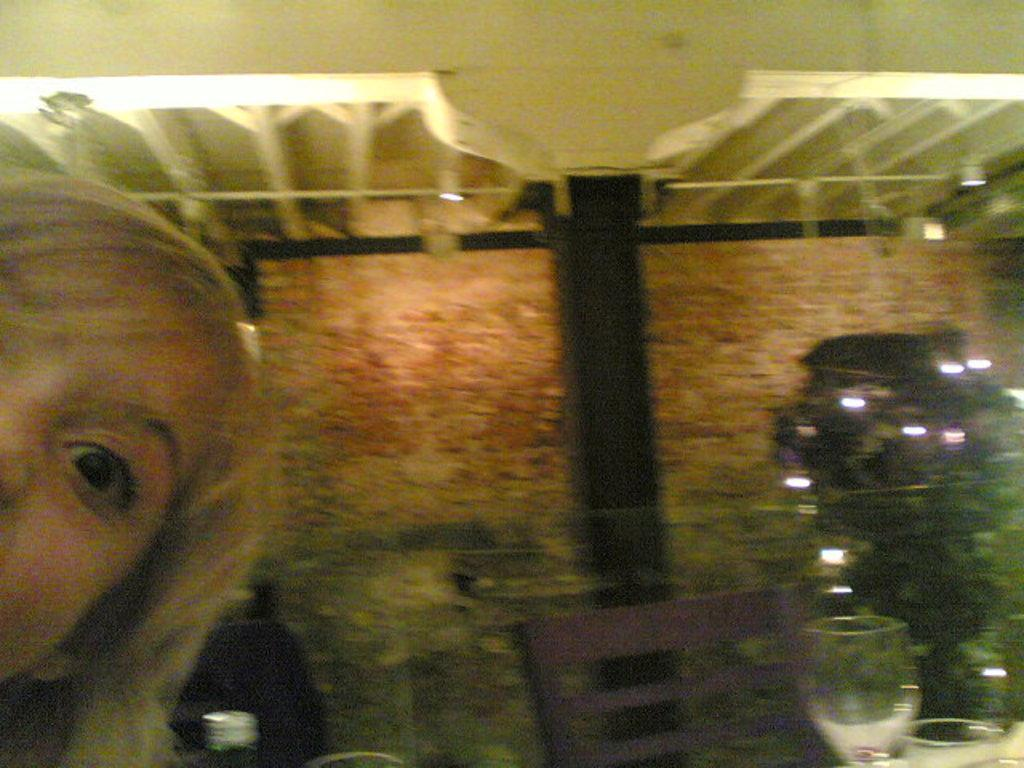Who is on the left side of the image? There is a lady on the left side of the image. What objects are present in the image for sitting? There are chairs in the image. What can be seen in the background of the image? There is a wall in the background of the image. What is visible at the top of the image? There is a roof visible at the top of the image. What objects are on the bottom right of the image? There are glasses on the bottom right of the image. What type of branch is hanging from the roof in the image? There is no branch hanging from the roof in the image. What is the lady carrying in the basket in the image? There is no basket or any items being carried by the lady in the image. 